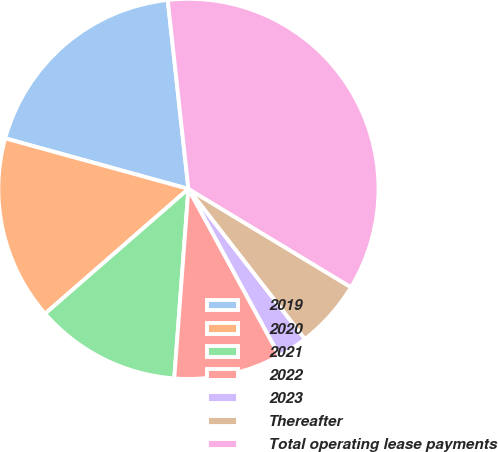Convert chart. <chart><loc_0><loc_0><loc_500><loc_500><pie_chart><fcel>2019<fcel>2020<fcel>2021<fcel>2022<fcel>2023<fcel>Thereafter<fcel>Total operating lease payments<nl><fcel>18.98%<fcel>15.69%<fcel>12.41%<fcel>9.13%<fcel>2.56%<fcel>5.84%<fcel>35.4%<nl></chart> 